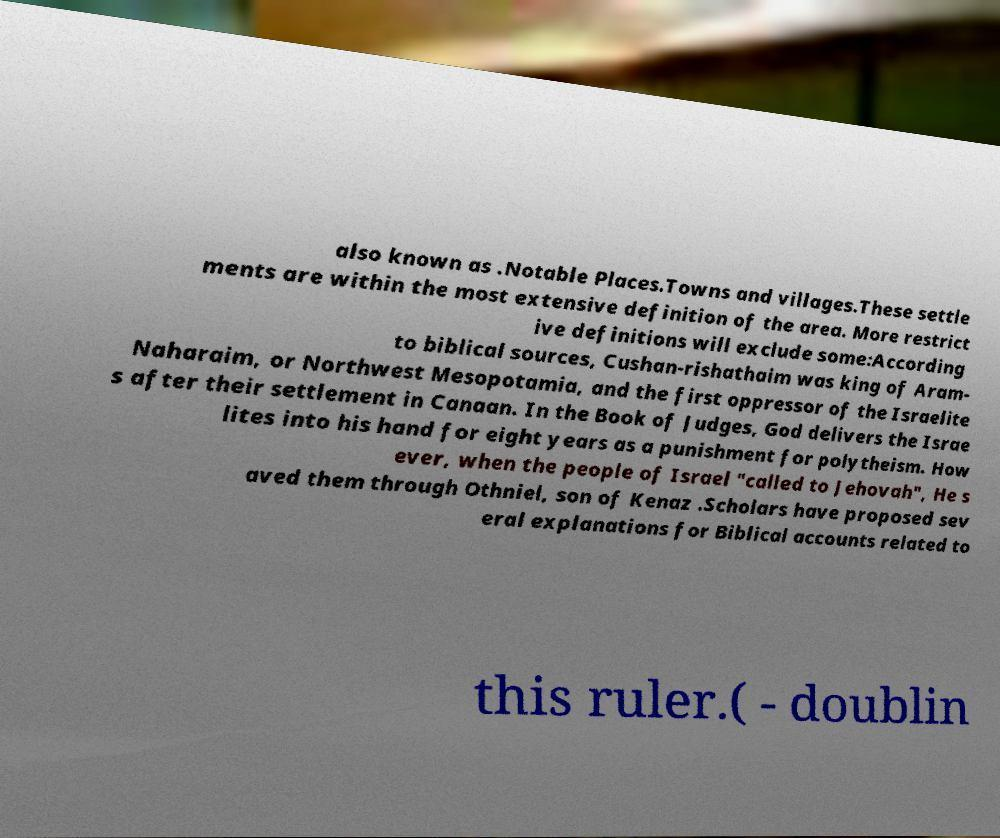Please read and relay the text visible in this image. What does it say? also known as .Notable Places.Towns and villages.These settle ments are within the most extensive definition of the area. More restrict ive definitions will exclude some:According to biblical sources, Cushan-rishathaim was king of Aram- Naharaim, or Northwest Mesopotamia, and the first oppressor of the Israelite s after their settlement in Canaan. In the Book of Judges, God delivers the Israe lites into his hand for eight years as a punishment for polytheism. How ever, when the people of Israel "called to Jehovah", He s aved them through Othniel, son of Kenaz .Scholars have proposed sev eral explanations for Biblical accounts related to this ruler.( - doublin 